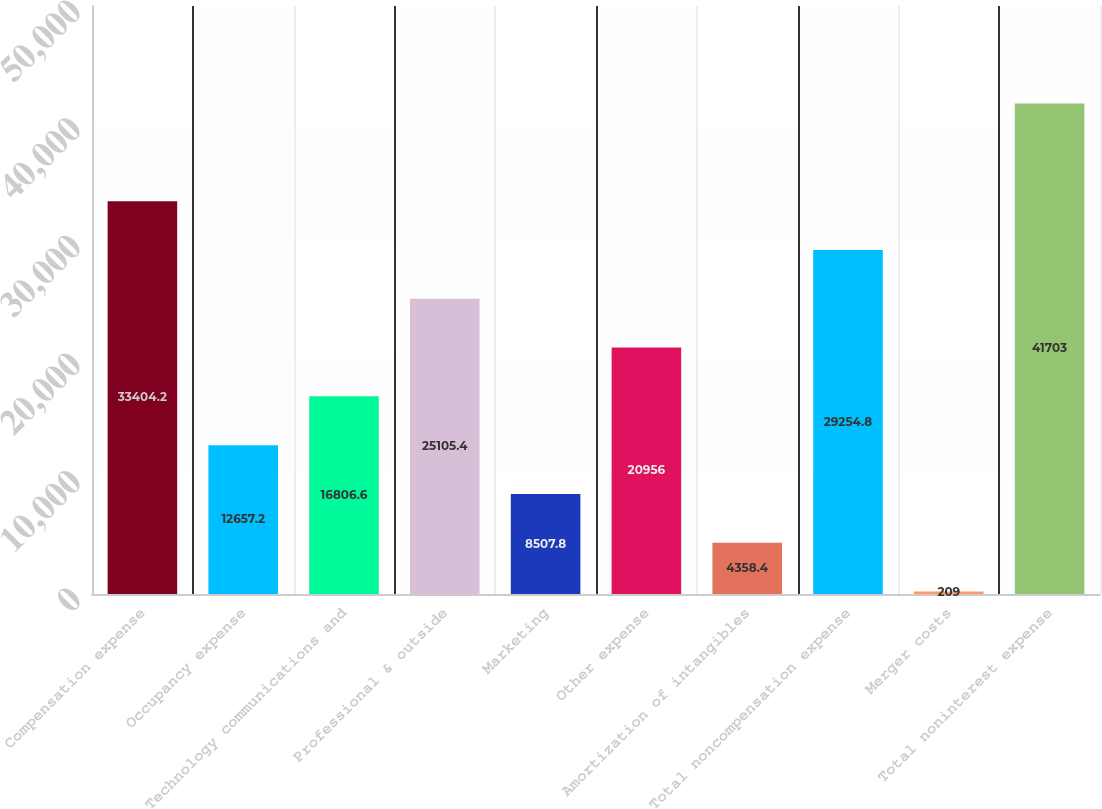<chart> <loc_0><loc_0><loc_500><loc_500><bar_chart><fcel>Compensation expense<fcel>Occupancy expense<fcel>Technology communications and<fcel>Professional & outside<fcel>Marketing<fcel>Other expense<fcel>Amortization of intangibles<fcel>Total noncompensation expense<fcel>Merger costs<fcel>Total noninterest expense<nl><fcel>33404.2<fcel>12657.2<fcel>16806.6<fcel>25105.4<fcel>8507.8<fcel>20956<fcel>4358.4<fcel>29254.8<fcel>209<fcel>41703<nl></chart> 